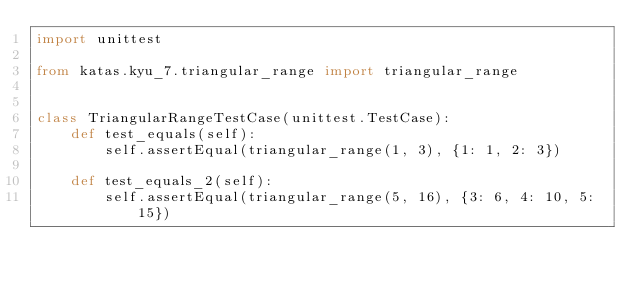Convert code to text. <code><loc_0><loc_0><loc_500><loc_500><_Python_>import unittest

from katas.kyu_7.triangular_range import triangular_range


class TriangularRangeTestCase(unittest.TestCase):
    def test_equals(self):
        self.assertEqual(triangular_range(1, 3), {1: 1, 2: 3})

    def test_equals_2(self):
        self.assertEqual(triangular_range(5, 16), {3: 6, 4: 10, 5: 15})
</code> 